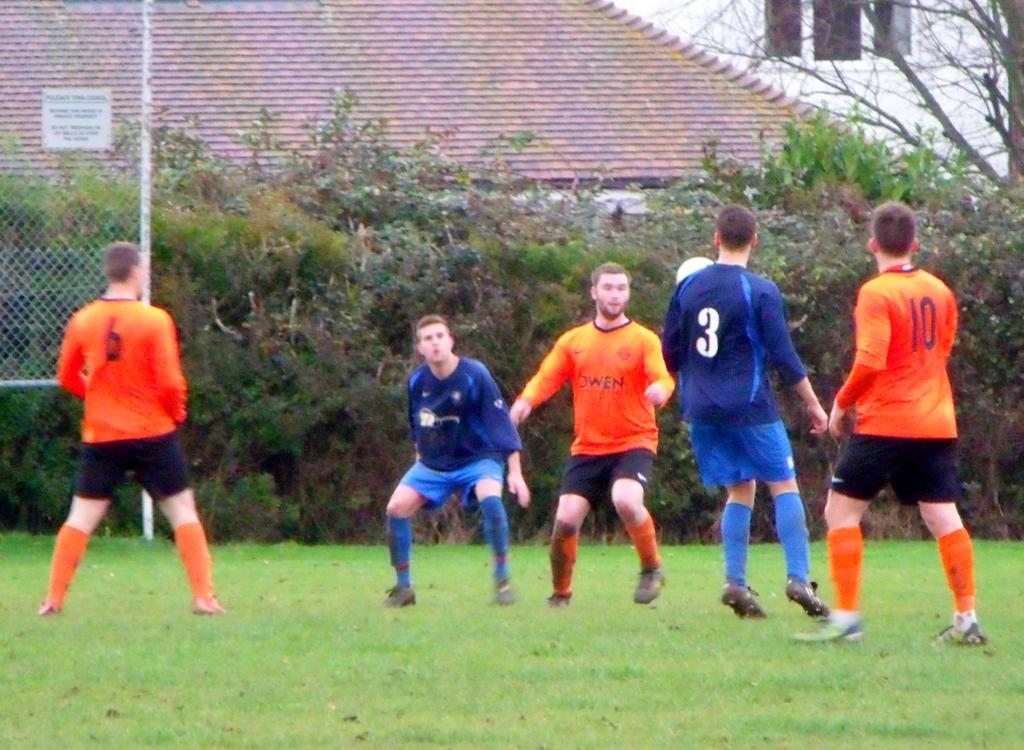<image>
Give a short and clear explanation of the subsequent image. a soccer team with one of the players wearing the number 3 uniform 